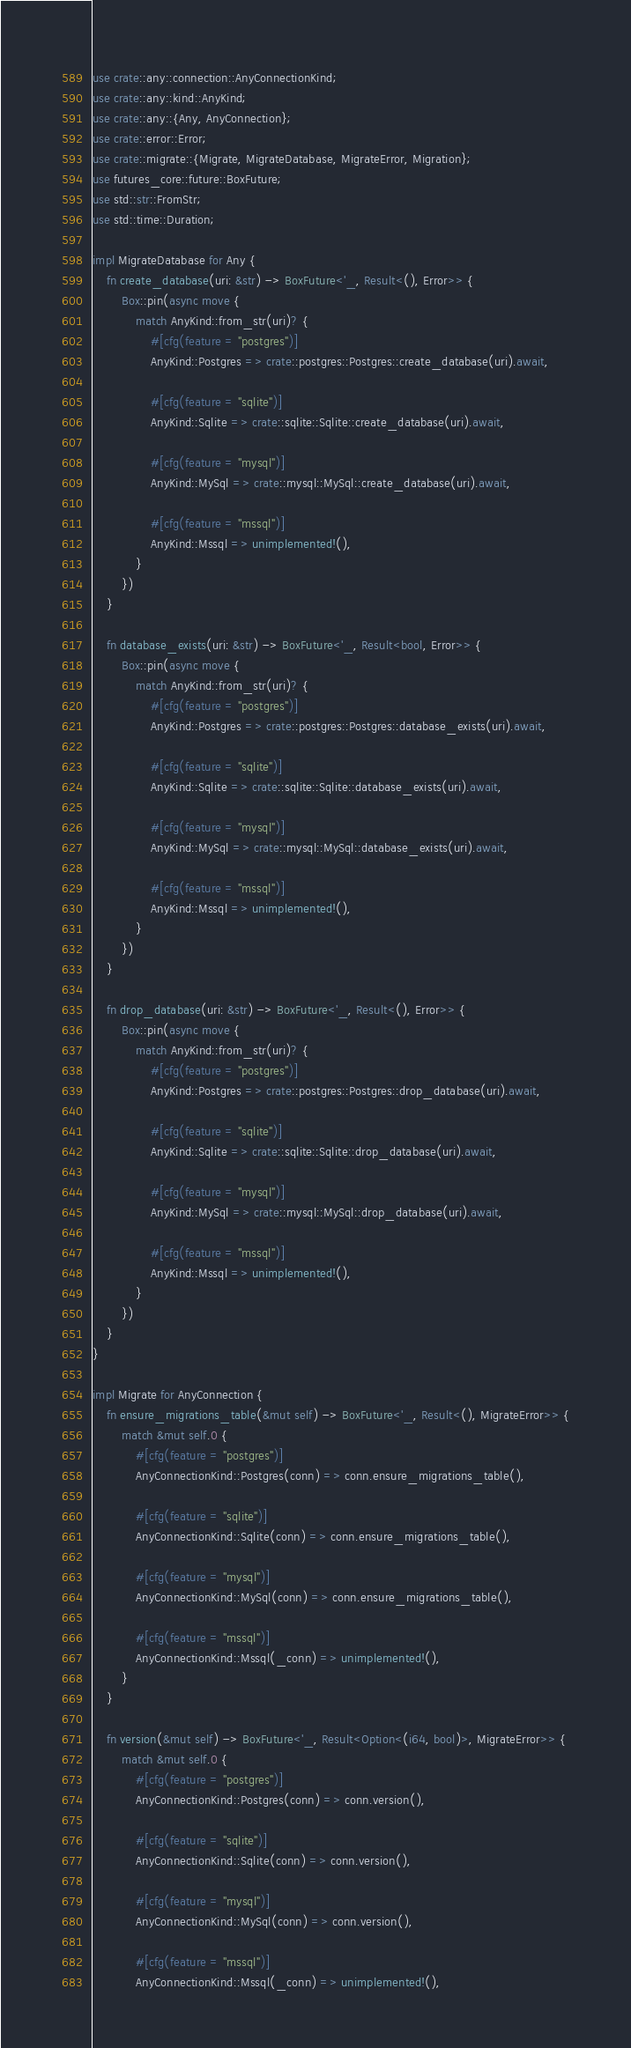<code> <loc_0><loc_0><loc_500><loc_500><_Rust_>use crate::any::connection::AnyConnectionKind;
use crate::any::kind::AnyKind;
use crate::any::{Any, AnyConnection};
use crate::error::Error;
use crate::migrate::{Migrate, MigrateDatabase, MigrateError, Migration};
use futures_core::future::BoxFuture;
use std::str::FromStr;
use std::time::Duration;

impl MigrateDatabase for Any {
    fn create_database(uri: &str) -> BoxFuture<'_, Result<(), Error>> {
        Box::pin(async move {
            match AnyKind::from_str(uri)? {
                #[cfg(feature = "postgres")]
                AnyKind::Postgres => crate::postgres::Postgres::create_database(uri).await,

                #[cfg(feature = "sqlite")]
                AnyKind::Sqlite => crate::sqlite::Sqlite::create_database(uri).await,

                #[cfg(feature = "mysql")]
                AnyKind::MySql => crate::mysql::MySql::create_database(uri).await,

                #[cfg(feature = "mssql")]
                AnyKind::Mssql => unimplemented!(),
            }
        })
    }

    fn database_exists(uri: &str) -> BoxFuture<'_, Result<bool, Error>> {
        Box::pin(async move {
            match AnyKind::from_str(uri)? {
                #[cfg(feature = "postgres")]
                AnyKind::Postgres => crate::postgres::Postgres::database_exists(uri).await,

                #[cfg(feature = "sqlite")]
                AnyKind::Sqlite => crate::sqlite::Sqlite::database_exists(uri).await,

                #[cfg(feature = "mysql")]
                AnyKind::MySql => crate::mysql::MySql::database_exists(uri).await,

                #[cfg(feature = "mssql")]
                AnyKind::Mssql => unimplemented!(),
            }
        })
    }

    fn drop_database(uri: &str) -> BoxFuture<'_, Result<(), Error>> {
        Box::pin(async move {
            match AnyKind::from_str(uri)? {
                #[cfg(feature = "postgres")]
                AnyKind::Postgres => crate::postgres::Postgres::drop_database(uri).await,

                #[cfg(feature = "sqlite")]
                AnyKind::Sqlite => crate::sqlite::Sqlite::drop_database(uri).await,

                #[cfg(feature = "mysql")]
                AnyKind::MySql => crate::mysql::MySql::drop_database(uri).await,

                #[cfg(feature = "mssql")]
                AnyKind::Mssql => unimplemented!(),
            }
        })
    }
}

impl Migrate for AnyConnection {
    fn ensure_migrations_table(&mut self) -> BoxFuture<'_, Result<(), MigrateError>> {
        match &mut self.0 {
            #[cfg(feature = "postgres")]
            AnyConnectionKind::Postgres(conn) => conn.ensure_migrations_table(),

            #[cfg(feature = "sqlite")]
            AnyConnectionKind::Sqlite(conn) => conn.ensure_migrations_table(),

            #[cfg(feature = "mysql")]
            AnyConnectionKind::MySql(conn) => conn.ensure_migrations_table(),

            #[cfg(feature = "mssql")]
            AnyConnectionKind::Mssql(_conn) => unimplemented!(),
        }
    }

    fn version(&mut self) -> BoxFuture<'_, Result<Option<(i64, bool)>, MigrateError>> {
        match &mut self.0 {
            #[cfg(feature = "postgres")]
            AnyConnectionKind::Postgres(conn) => conn.version(),

            #[cfg(feature = "sqlite")]
            AnyConnectionKind::Sqlite(conn) => conn.version(),

            #[cfg(feature = "mysql")]
            AnyConnectionKind::MySql(conn) => conn.version(),

            #[cfg(feature = "mssql")]
            AnyConnectionKind::Mssql(_conn) => unimplemented!(),</code> 